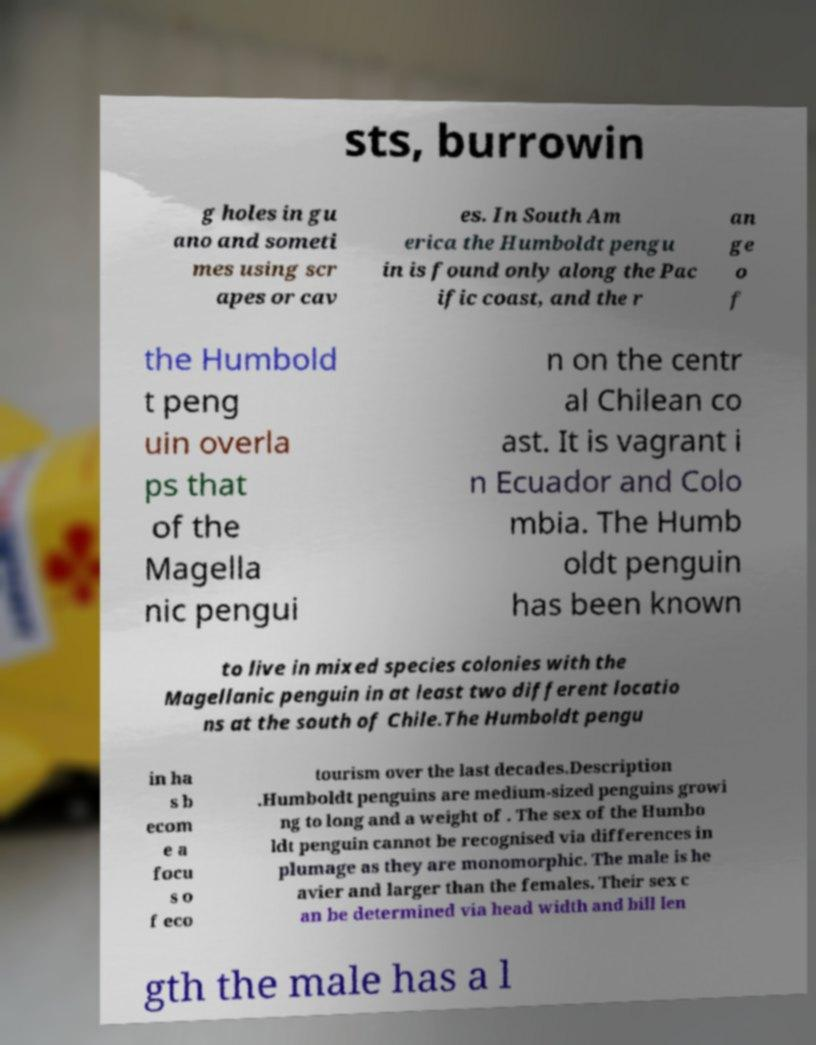There's text embedded in this image that I need extracted. Can you transcribe it verbatim? sts, burrowin g holes in gu ano and someti mes using scr apes or cav es. In South Am erica the Humboldt pengu in is found only along the Pac ific coast, and the r an ge o f the Humbold t peng uin overla ps that of the Magella nic pengui n on the centr al Chilean co ast. It is vagrant i n Ecuador and Colo mbia. The Humb oldt penguin has been known to live in mixed species colonies with the Magellanic penguin in at least two different locatio ns at the south of Chile.The Humboldt pengu in ha s b ecom e a focu s o f eco tourism over the last decades.Description .Humboldt penguins are medium-sized penguins growi ng to long and a weight of . The sex of the Humbo ldt penguin cannot be recognised via differences in plumage as they are monomorphic. The male is he avier and larger than the females. Their sex c an be determined via head width and bill len gth the male has a l 